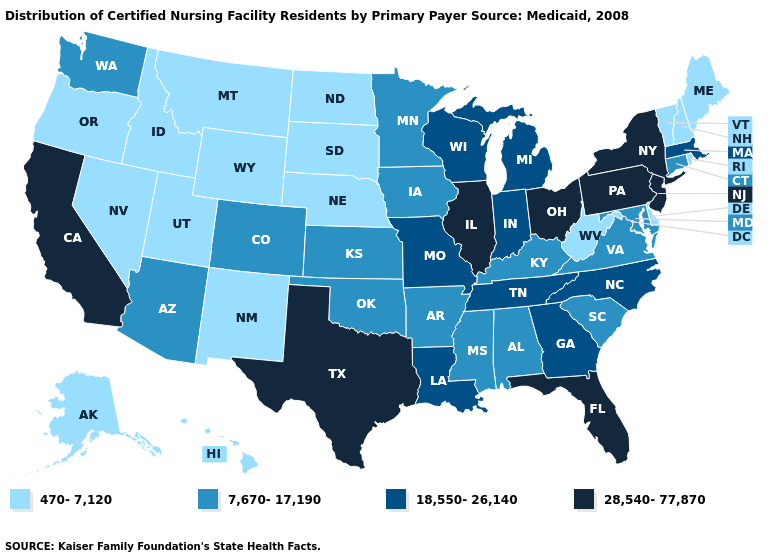Among the states that border Tennessee , which have the highest value?
Keep it brief. Georgia, Missouri, North Carolina. Does New Hampshire have a higher value than Michigan?
Concise answer only. No. Does the first symbol in the legend represent the smallest category?
Concise answer only. Yes. What is the highest value in the USA?
Concise answer only. 28,540-77,870. What is the highest value in the USA?
Quick response, please. 28,540-77,870. Name the states that have a value in the range 18,550-26,140?
Concise answer only. Georgia, Indiana, Louisiana, Massachusetts, Michigan, Missouri, North Carolina, Tennessee, Wisconsin. Is the legend a continuous bar?
Answer briefly. No. Which states have the lowest value in the Northeast?
Concise answer only. Maine, New Hampshire, Rhode Island, Vermont. What is the lowest value in states that border Georgia?
Write a very short answer. 7,670-17,190. Which states have the highest value in the USA?
Short answer required. California, Florida, Illinois, New Jersey, New York, Ohio, Pennsylvania, Texas. What is the highest value in states that border Florida?
Concise answer only. 18,550-26,140. Does California have the highest value in the West?
Give a very brief answer. Yes. What is the value of Oklahoma?
Keep it brief. 7,670-17,190. What is the value of New Hampshire?
Concise answer only. 470-7,120. What is the value of Maryland?
Keep it brief. 7,670-17,190. 